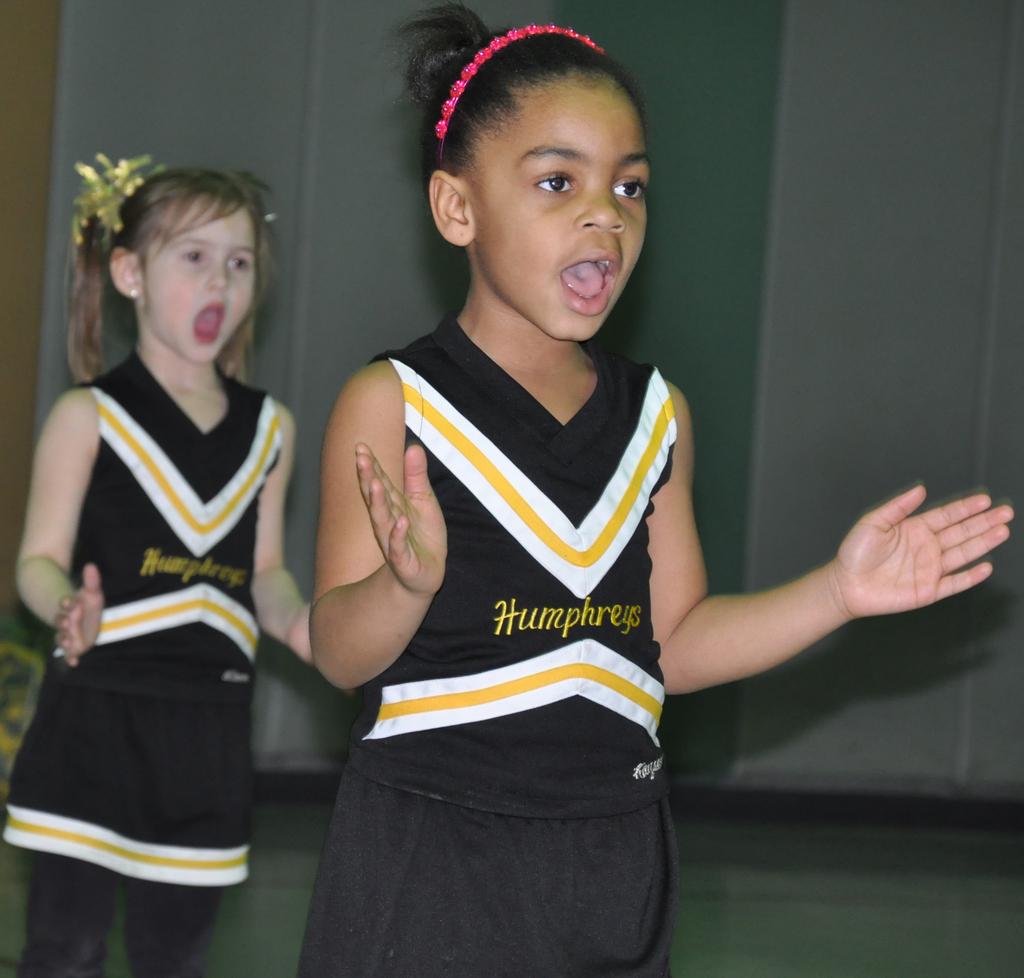What school does this girl go to?
Provide a succinct answer. Humphreys. 